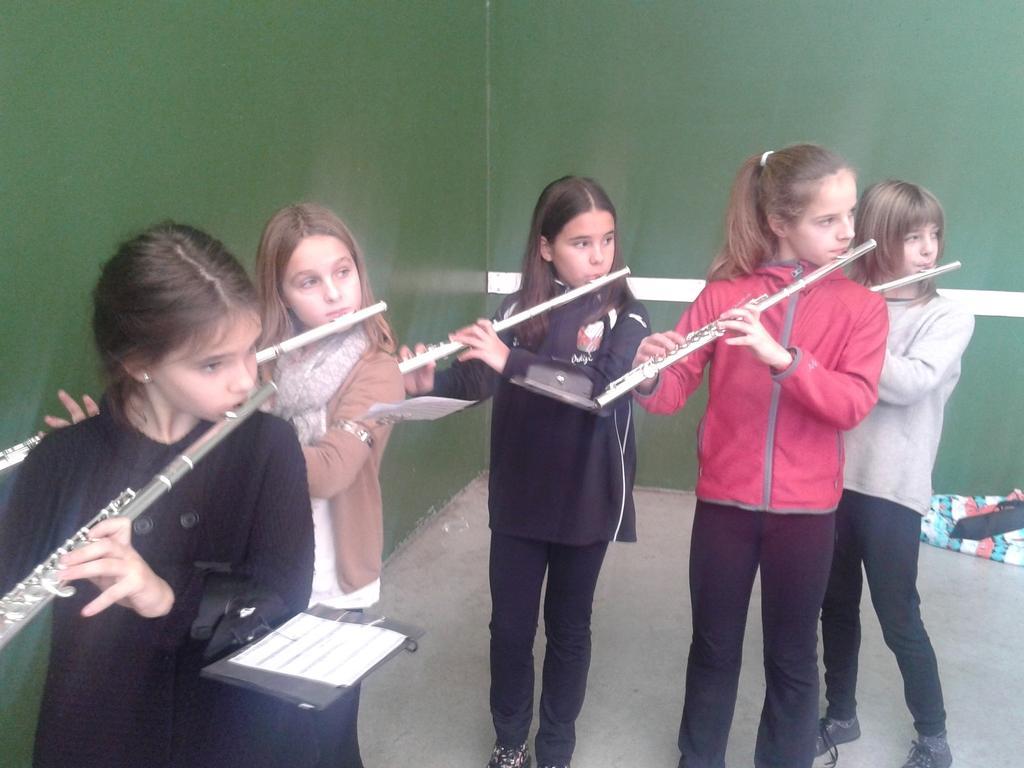Describe this image in one or two sentences. In this image I see 5 girls and all of them are holding flutes and In the background I see the wall. 